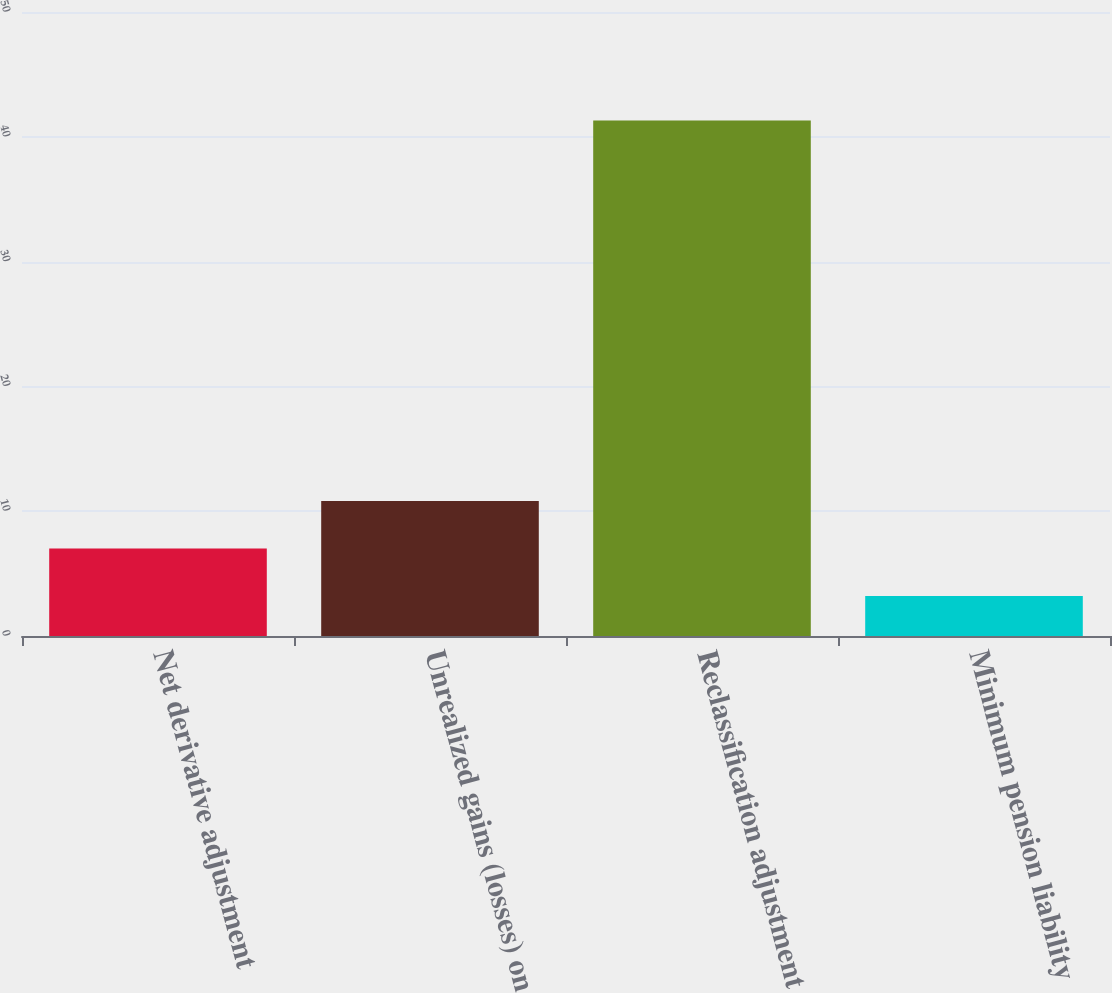<chart> <loc_0><loc_0><loc_500><loc_500><bar_chart><fcel>Net derivative adjustment<fcel>Unrealized gains (losses) on<fcel>Reclassification adjustment<fcel>Minimum pension liability<nl><fcel>7.01<fcel>10.82<fcel>41.3<fcel>3.2<nl></chart> 